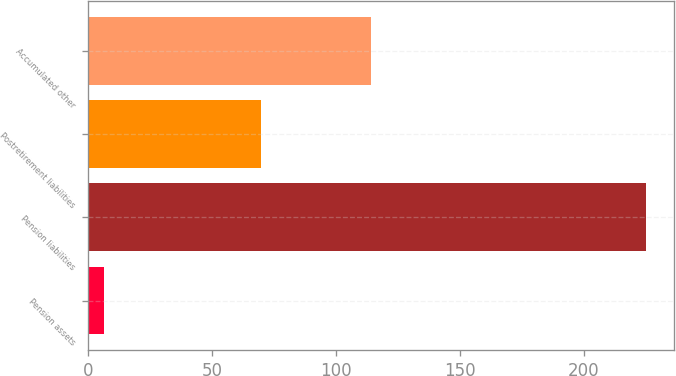Convert chart to OTSL. <chart><loc_0><loc_0><loc_500><loc_500><bar_chart><fcel>Pension assets<fcel>Pension liabilities<fcel>Postretirement liabilities<fcel>Accumulated other<nl><fcel>6.2<fcel>225.2<fcel>69.9<fcel>114.3<nl></chart> 